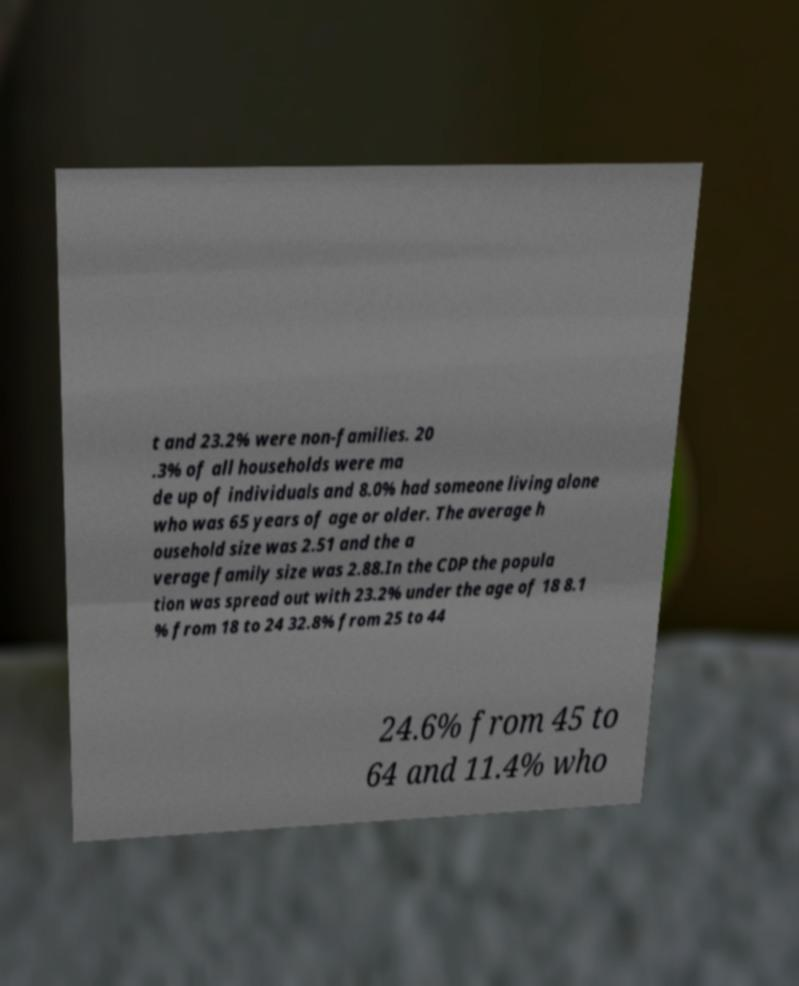Please identify and transcribe the text found in this image. t and 23.2% were non-families. 20 .3% of all households were ma de up of individuals and 8.0% had someone living alone who was 65 years of age or older. The average h ousehold size was 2.51 and the a verage family size was 2.88.In the CDP the popula tion was spread out with 23.2% under the age of 18 8.1 % from 18 to 24 32.8% from 25 to 44 24.6% from 45 to 64 and 11.4% who 